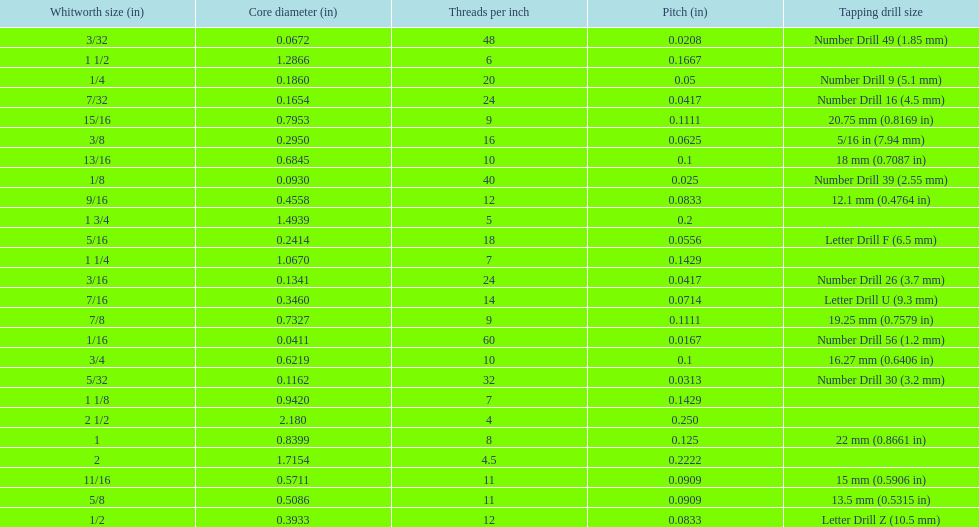Could you parse the entire table? {'header': ['Whitworth size (in)', 'Core diameter (in)', 'Threads per\xa0inch', 'Pitch (in)', 'Tapping drill size'], 'rows': [['3/32', '0.0672', '48', '0.0208', 'Number Drill 49 (1.85\xa0mm)'], ['1 1/2', '1.2866', '6', '0.1667', ''], ['1/4', '0.1860', '20', '0.05', 'Number Drill 9 (5.1\xa0mm)'], ['7/32', '0.1654', '24', '0.0417', 'Number Drill 16 (4.5\xa0mm)'], ['15/16', '0.7953', '9', '0.1111', '20.75\xa0mm (0.8169\xa0in)'], ['3/8', '0.2950', '16', '0.0625', '5/16\xa0in (7.94\xa0mm)'], ['13/16', '0.6845', '10', '0.1', '18\xa0mm (0.7087\xa0in)'], ['1/8', '0.0930', '40', '0.025', 'Number Drill 39 (2.55\xa0mm)'], ['9/16', '0.4558', '12', '0.0833', '12.1\xa0mm (0.4764\xa0in)'], ['1 3/4', '1.4939', '5', '0.2', ''], ['5/16', '0.2414', '18', '0.0556', 'Letter Drill F (6.5\xa0mm)'], ['1 1/4', '1.0670', '7', '0.1429', ''], ['3/16', '0.1341', '24', '0.0417', 'Number Drill 26 (3.7\xa0mm)'], ['7/16', '0.3460', '14', '0.0714', 'Letter Drill U (9.3\xa0mm)'], ['7/8', '0.7327', '9', '0.1111', '19.25\xa0mm (0.7579\xa0in)'], ['1/16', '0.0411', '60', '0.0167', 'Number Drill 56 (1.2\xa0mm)'], ['3/4', '0.6219', '10', '0.1', '16.27\xa0mm (0.6406\xa0in)'], ['5/32', '0.1162', '32', '0.0313', 'Number Drill 30 (3.2\xa0mm)'], ['1 1/8', '0.9420', '7', '0.1429', ''], ['2 1/2', '2.180', '4', '0.250', ''], ['1', '0.8399', '8', '0.125', '22\xa0mm (0.8661\xa0in)'], ['2', '1.7154', '4.5', '0.2222', ''], ['11/16', '0.5711', '11', '0.0909', '15\xa0mm (0.5906\xa0in)'], ['5/8', '0.5086', '11', '0.0909', '13.5\xa0mm (0.5315\xa0in)'], ['1/2', '0.3933', '12', '0.0833', 'Letter Drill Z (10.5\xa0mm)']]} Which whitworth size is the only one with 5 threads per inch? 1 3/4. 